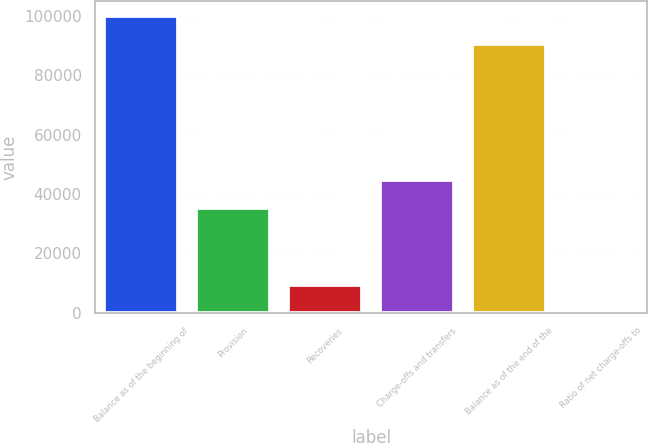Convert chart. <chart><loc_0><loc_0><loc_500><loc_500><bar_chart><fcel>Balance as of the beginning of<fcel>Provision<fcel>Recoveries<fcel>Charge-offs and transfers<fcel>Balance as of the end of the<fcel>Ratio of net charge-offs to<nl><fcel>99839.9<fcel>35200<fcel>9358.86<fcel>44552.9<fcel>90487<fcel>5.96<nl></chart> 